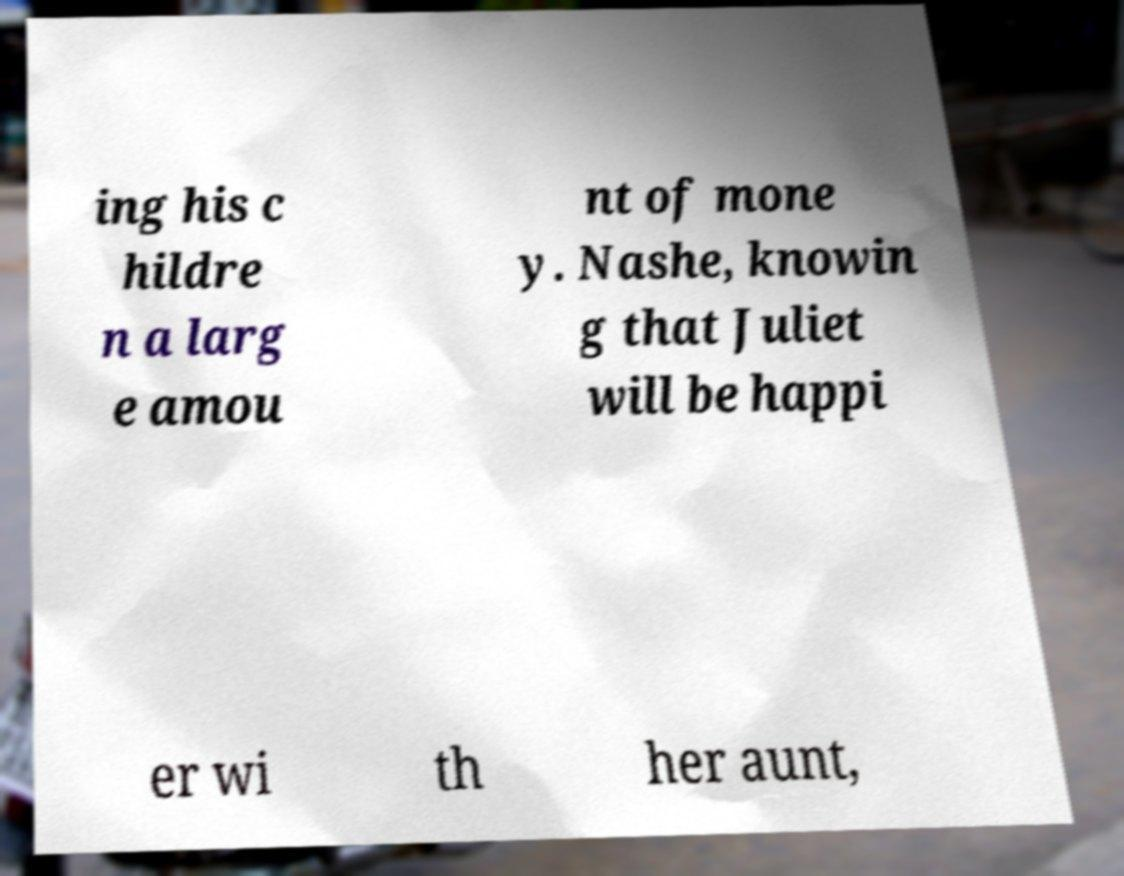I need the written content from this picture converted into text. Can you do that? ing his c hildre n a larg e amou nt of mone y. Nashe, knowin g that Juliet will be happi er wi th her aunt, 